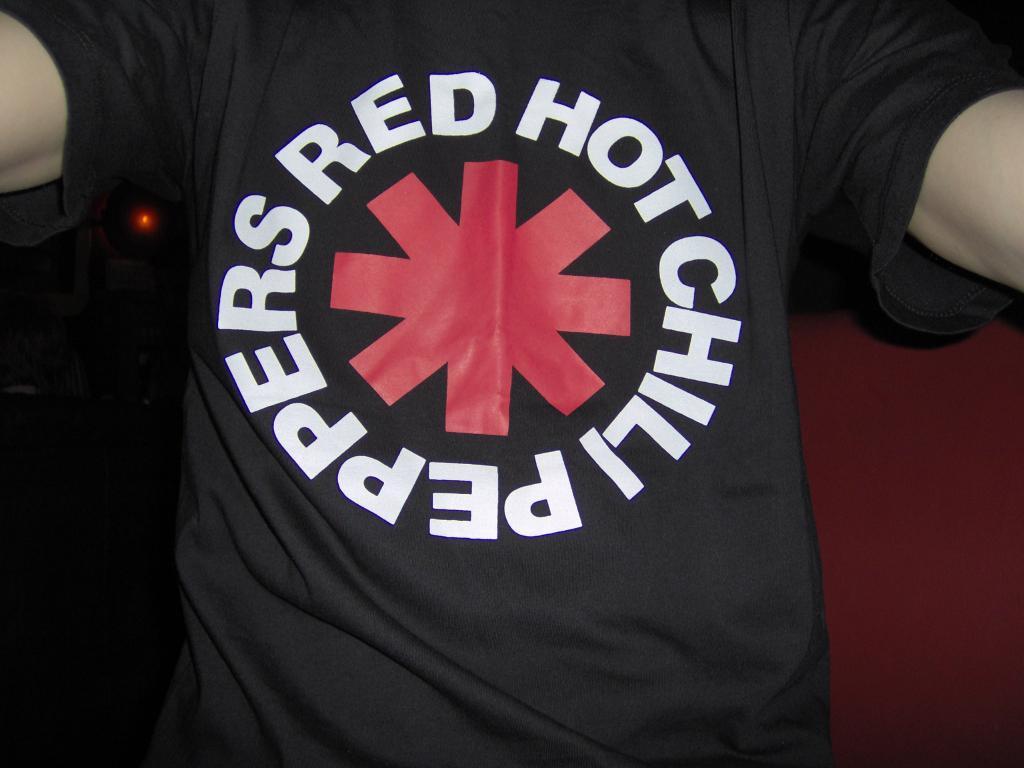What band is this from?
Your answer should be compact. Red hot chili peppers. What color are the chili peppers?
Give a very brief answer. Red. 